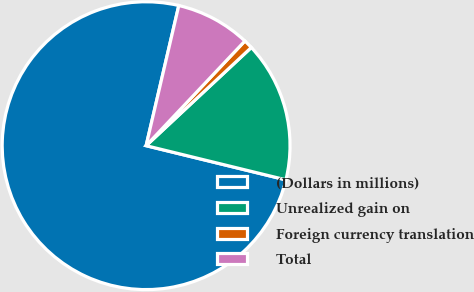Convert chart to OTSL. <chart><loc_0><loc_0><loc_500><loc_500><pie_chart><fcel>(Dollars in millions)<fcel>Unrealized gain on<fcel>Foreign currency translation<fcel>Total<nl><fcel>74.83%<fcel>15.77%<fcel>1.01%<fcel>8.39%<nl></chart> 